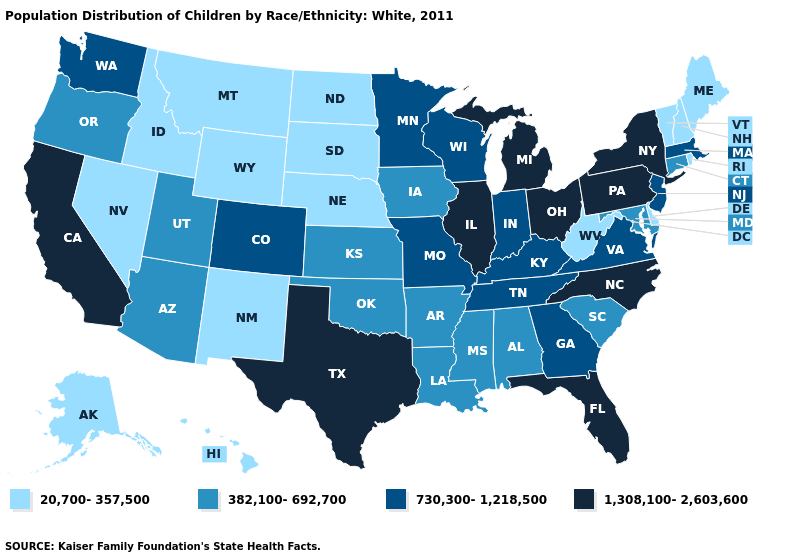What is the lowest value in the Northeast?
Be succinct. 20,700-357,500. Does the map have missing data?
Quick response, please. No. Name the states that have a value in the range 730,300-1,218,500?
Short answer required. Colorado, Georgia, Indiana, Kentucky, Massachusetts, Minnesota, Missouri, New Jersey, Tennessee, Virginia, Washington, Wisconsin. Does Florida have the highest value in the USA?
Keep it brief. Yes. Is the legend a continuous bar?
Short answer required. No. Name the states that have a value in the range 20,700-357,500?
Concise answer only. Alaska, Delaware, Hawaii, Idaho, Maine, Montana, Nebraska, Nevada, New Hampshire, New Mexico, North Dakota, Rhode Island, South Dakota, Vermont, West Virginia, Wyoming. Does the first symbol in the legend represent the smallest category?
Give a very brief answer. Yes. Name the states that have a value in the range 730,300-1,218,500?
Be succinct. Colorado, Georgia, Indiana, Kentucky, Massachusetts, Minnesota, Missouri, New Jersey, Tennessee, Virginia, Washington, Wisconsin. What is the lowest value in the MidWest?
Give a very brief answer. 20,700-357,500. Does the map have missing data?
Answer briefly. No. Does Connecticut have the lowest value in the Northeast?
Quick response, please. No. What is the value of Utah?
Short answer required. 382,100-692,700. What is the lowest value in states that border Colorado?
Write a very short answer. 20,700-357,500. What is the value of Wyoming?
Give a very brief answer. 20,700-357,500. 